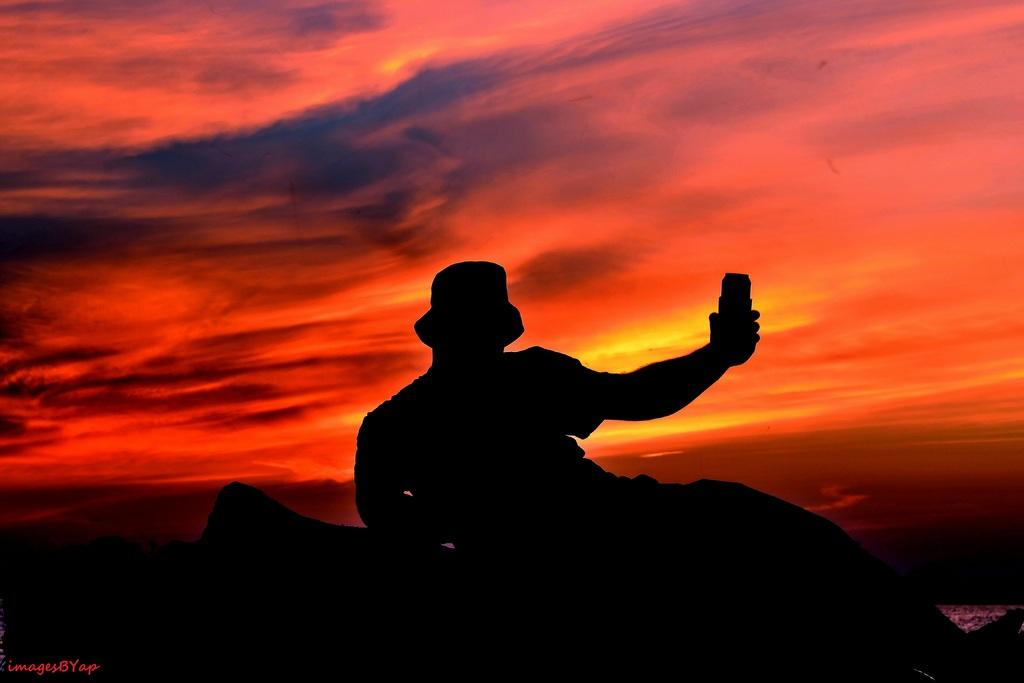What is the main subject of the image? There is a depiction of a person in the image. What can be seen in the background of the image? The sky is visible at the top of the image. What type of berry is being squeezed in the image? There is no berry present in the image. What role does the calculator play in the image? There is no calculator present in the image. 